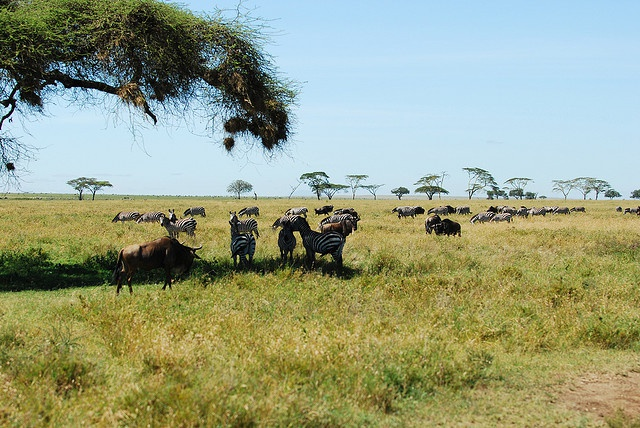Describe the objects in this image and their specific colors. I can see cow in black, olive, tan, and maroon tones, zebra in black, gray, purple, and tan tones, zebra in black, olive, gray, and darkgreen tones, zebra in black, tan, gray, and darkgray tones, and zebra in black, gray, darkgreen, and darkgray tones in this image. 